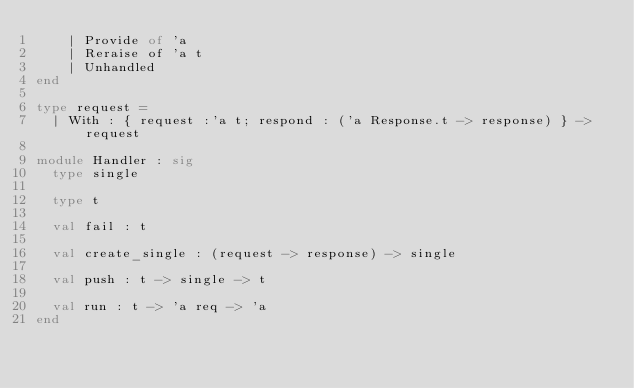Convert code to text. <code><loc_0><loc_0><loc_500><loc_500><_OCaml_>    | Provide of 'a
    | Reraise of 'a t
    | Unhandled
end

type request =
  | With : { request :'a t; respond : ('a Response.t -> response) } -> request

module Handler : sig
  type single

  type t

  val fail : t

  val create_single : (request -> response) -> single

  val push : t -> single -> t

  val run : t -> 'a req -> 'a
end
</code> 